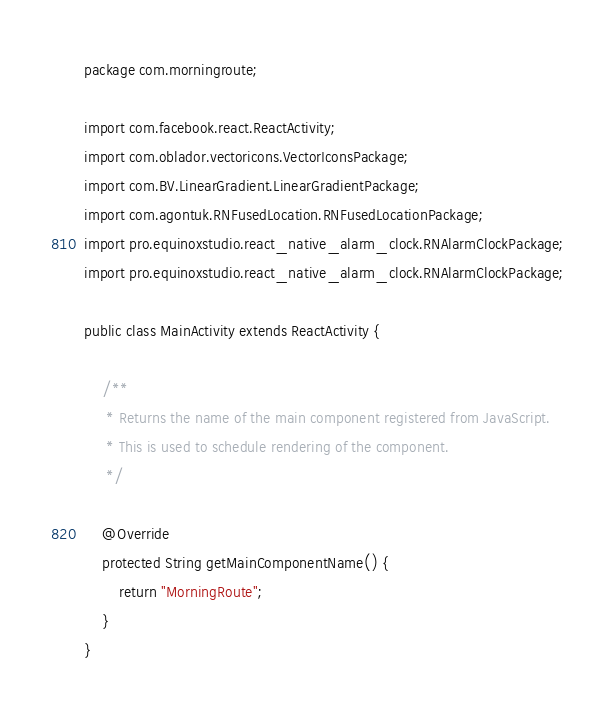<code> <loc_0><loc_0><loc_500><loc_500><_Java_>package com.morningroute;

import com.facebook.react.ReactActivity;
import com.oblador.vectoricons.VectorIconsPackage;
import com.BV.LinearGradient.LinearGradientPackage;
import com.agontuk.RNFusedLocation.RNFusedLocationPackage;
import pro.equinoxstudio.react_native_alarm_clock.RNAlarmClockPackage;
import pro.equinoxstudio.react_native_alarm_clock.RNAlarmClockPackage;

public class MainActivity extends ReactActivity {

    /**
     * Returns the name of the main component registered from JavaScript.
     * This is used to schedule rendering of the component.
     */
  
    @Override
    protected String getMainComponentName() {
        return "MorningRoute";
    }
}
</code> 